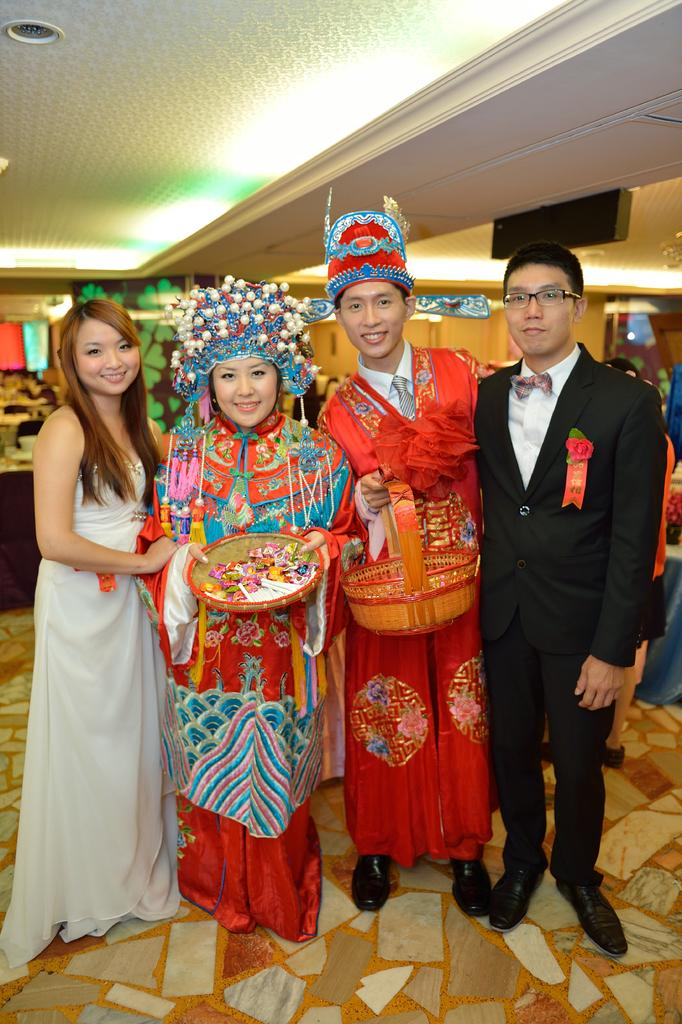How many people are in the image? There are people in the image. Can you describe the two main subjects in the image? A man and a woman are present in the middle of the image. What are the man and woman holding in their hands? The man and woman are holding baskets in their hands. What can be seen in the background or surroundings of the image? There are lights visible in the image. What type of rifle is the man holding in the image? There is no rifle present in the image; the man and woman are holding baskets. 